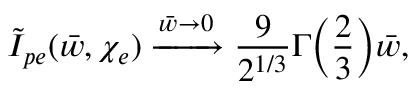<formula> <loc_0><loc_0><loc_500><loc_500>\tilde { I } _ { p e } ( \bar { w } , \chi _ { e } ) \xrightarrow { \bar { w } \to 0 } \frac { 9 } { 2 ^ { 1 / 3 } } \Gamma \left ( \frac { 2 } { 3 } \right ) \bar { w } ,</formula> 